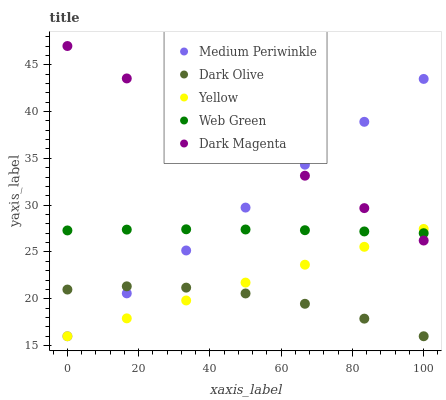Does Dark Olive have the minimum area under the curve?
Answer yes or no. Yes. Does Dark Magenta have the maximum area under the curve?
Answer yes or no. Yes. Does Medium Periwinkle have the minimum area under the curve?
Answer yes or no. No. Does Medium Periwinkle have the maximum area under the curve?
Answer yes or no. No. Is Dark Magenta the smoothest?
Answer yes or no. Yes. Is Dark Olive the roughest?
Answer yes or no. Yes. Is Medium Periwinkle the smoothest?
Answer yes or no. No. Is Medium Periwinkle the roughest?
Answer yes or no. No. Does Dark Olive have the lowest value?
Answer yes or no. Yes. Does Web Green have the lowest value?
Answer yes or no. No. Does Dark Magenta have the highest value?
Answer yes or no. Yes. Does Medium Periwinkle have the highest value?
Answer yes or no. No. Is Dark Olive less than Web Green?
Answer yes or no. Yes. Is Web Green greater than Dark Olive?
Answer yes or no. Yes. Does Web Green intersect Medium Periwinkle?
Answer yes or no. Yes. Is Web Green less than Medium Periwinkle?
Answer yes or no. No. Is Web Green greater than Medium Periwinkle?
Answer yes or no. No. Does Dark Olive intersect Web Green?
Answer yes or no. No. 